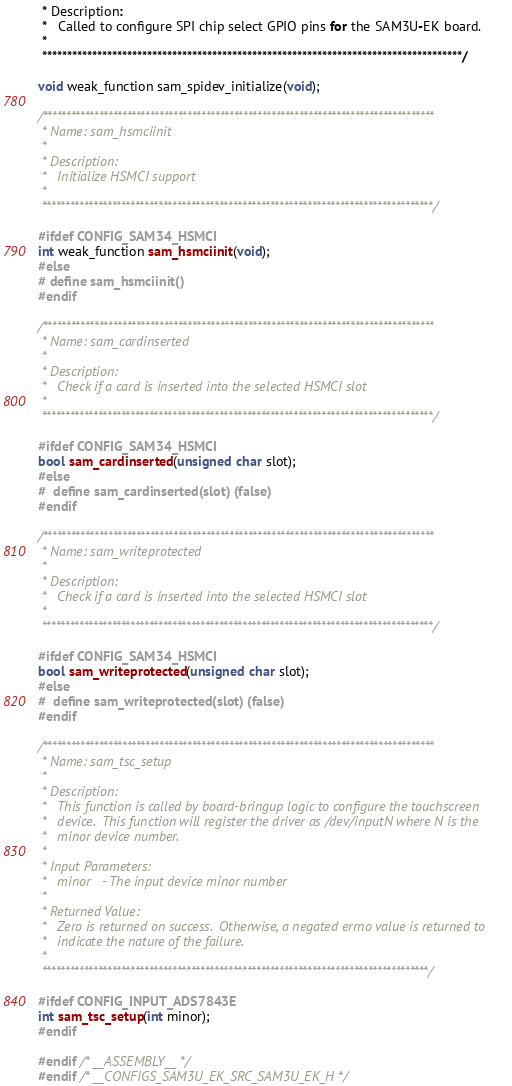Convert code to text. <code><loc_0><loc_0><loc_500><loc_500><_C_> * Description:
 *   Called to configure SPI chip select GPIO pins for the SAM3U-EK board.
 *
 ************************************************************************************/

void weak_function sam_spidev_initialize(void);

/************************************************************************************
 * Name: sam_hsmciinit
 *
 * Description:
 *   Initialize HSMCI support
 *
 ************************************************************************************/

#ifdef CONFIG_SAM34_HSMCI
int weak_function sam_hsmciinit(void);
#else
# define sam_hsmciinit()
#endif

/************************************************************************************
 * Name: sam_cardinserted
 *
 * Description:
 *   Check if a card is inserted into the selected HSMCI slot
 *
 ************************************************************************************/

#ifdef CONFIG_SAM34_HSMCI
bool sam_cardinserted(unsigned char slot);
#else
#  define sam_cardinserted(slot) (false)
#endif

/************************************************************************************
 * Name: sam_writeprotected
 *
 * Description:
 *   Check if a card is inserted into the selected HSMCI slot
 *
 ************************************************************************************/

#ifdef CONFIG_SAM34_HSMCI
bool sam_writeprotected(unsigned char slot);
#else
#  define sam_writeprotected(slot) (false)
#endif

/************************************************************************************
 * Name: sam_tsc_setup
 *
 * Description:
 *   This function is called by board-bringup logic to configure the touchscreen
 *   device.  This function will register the driver as /dev/inputN where N is the
 *   minor device number.
 *
 * Input Parameters:
 *   minor   - The input device minor number
 *
 * Returned Value:
 *   Zero is returned on success.  Otherwise, a negated errno value is returned to
 *   indicate the nature of the failure.
 *
 ***********************************************************************************/

#ifdef CONFIG_INPUT_ADS7843E
int sam_tsc_setup(int minor);
#endif

#endif /* __ASSEMBLY__ */
#endif /* __CONFIGS_SAM3U_EK_SRC_SAM3U_EK_H */
</code> 